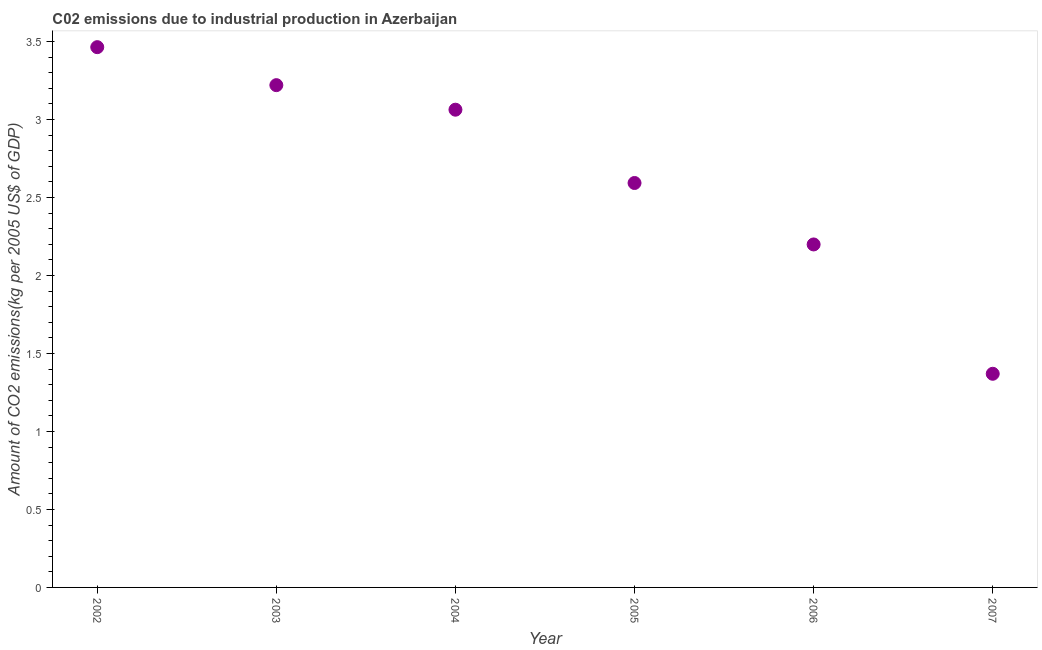What is the amount of co2 emissions in 2005?
Provide a short and direct response. 2.59. Across all years, what is the maximum amount of co2 emissions?
Your answer should be compact. 3.46. Across all years, what is the minimum amount of co2 emissions?
Your answer should be compact. 1.37. In which year was the amount of co2 emissions maximum?
Give a very brief answer. 2002. In which year was the amount of co2 emissions minimum?
Ensure brevity in your answer.  2007. What is the sum of the amount of co2 emissions?
Keep it short and to the point. 15.91. What is the difference between the amount of co2 emissions in 2005 and 2007?
Your response must be concise. 1.22. What is the average amount of co2 emissions per year?
Give a very brief answer. 2.65. What is the median amount of co2 emissions?
Your answer should be very brief. 2.83. In how many years, is the amount of co2 emissions greater than 0.4 kg per 2005 US$ of GDP?
Keep it short and to the point. 6. Do a majority of the years between 2005 and 2004 (inclusive) have amount of co2 emissions greater than 3.3 kg per 2005 US$ of GDP?
Offer a very short reply. No. What is the ratio of the amount of co2 emissions in 2003 to that in 2007?
Provide a succinct answer. 2.35. Is the amount of co2 emissions in 2003 less than that in 2005?
Offer a very short reply. No. What is the difference between the highest and the second highest amount of co2 emissions?
Provide a short and direct response. 0.24. What is the difference between the highest and the lowest amount of co2 emissions?
Offer a very short reply. 2.09. Does the amount of co2 emissions monotonically increase over the years?
Provide a succinct answer. No. What is the difference between two consecutive major ticks on the Y-axis?
Ensure brevity in your answer.  0.5. What is the title of the graph?
Make the answer very short. C02 emissions due to industrial production in Azerbaijan. What is the label or title of the X-axis?
Offer a very short reply. Year. What is the label or title of the Y-axis?
Provide a short and direct response. Amount of CO2 emissions(kg per 2005 US$ of GDP). What is the Amount of CO2 emissions(kg per 2005 US$ of GDP) in 2002?
Your response must be concise. 3.46. What is the Amount of CO2 emissions(kg per 2005 US$ of GDP) in 2003?
Give a very brief answer. 3.22. What is the Amount of CO2 emissions(kg per 2005 US$ of GDP) in 2004?
Keep it short and to the point. 3.06. What is the Amount of CO2 emissions(kg per 2005 US$ of GDP) in 2005?
Your answer should be very brief. 2.59. What is the Amount of CO2 emissions(kg per 2005 US$ of GDP) in 2006?
Your answer should be compact. 2.2. What is the Amount of CO2 emissions(kg per 2005 US$ of GDP) in 2007?
Your answer should be compact. 1.37. What is the difference between the Amount of CO2 emissions(kg per 2005 US$ of GDP) in 2002 and 2003?
Your answer should be very brief. 0.24. What is the difference between the Amount of CO2 emissions(kg per 2005 US$ of GDP) in 2002 and 2004?
Your answer should be compact. 0.4. What is the difference between the Amount of CO2 emissions(kg per 2005 US$ of GDP) in 2002 and 2005?
Keep it short and to the point. 0.87. What is the difference between the Amount of CO2 emissions(kg per 2005 US$ of GDP) in 2002 and 2006?
Your answer should be compact. 1.26. What is the difference between the Amount of CO2 emissions(kg per 2005 US$ of GDP) in 2002 and 2007?
Ensure brevity in your answer.  2.09. What is the difference between the Amount of CO2 emissions(kg per 2005 US$ of GDP) in 2003 and 2004?
Provide a succinct answer. 0.16. What is the difference between the Amount of CO2 emissions(kg per 2005 US$ of GDP) in 2003 and 2005?
Provide a short and direct response. 0.63. What is the difference between the Amount of CO2 emissions(kg per 2005 US$ of GDP) in 2003 and 2006?
Give a very brief answer. 1.02. What is the difference between the Amount of CO2 emissions(kg per 2005 US$ of GDP) in 2003 and 2007?
Ensure brevity in your answer.  1.85. What is the difference between the Amount of CO2 emissions(kg per 2005 US$ of GDP) in 2004 and 2005?
Provide a short and direct response. 0.47. What is the difference between the Amount of CO2 emissions(kg per 2005 US$ of GDP) in 2004 and 2006?
Offer a very short reply. 0.86. What is the difference between the Amount of CO2 emissions(kg per 2005 US$ of GDP) in 2004 and 2007?
Your response must be concise. 1.69. What is the difference between the Amount of CO2 emissions(kg per 2005 US$ of GDP) in 2005 and 2006?
Offer a terse response. 0.39. What is the difference between the Amount of CO2 emissions(kg per 2005 US$ of GDP) in 2005 and 2007?
Provide a short and direct response. 1.22. What is the difference between the Amount of CO2 emissions(kg per 2005 US$ of GDP) in 2006 and 2007?
Keep it short and to the point. 0.83. What is the ratio of the Amount of CO2 emissions(kg per 2005 US$ of GDP) in 2002 to that in 2003?
Your answer should be compact. 1.08. What is the ratio of the Amount of CO2 emissions(kg per 2005 US$ of GDP) in 2002 to that in 2004?
Give a very brief answer. 1.13. What is the ratio of the Amount of CO2 emissions(kg per 2005 US$ of GDP) in 2002 to that in 2005?
Ensure brevity in your answer.  1.34. What is the ratio of the Amount of CO2 emissions(kg per 2005 US$ of GDP) in 2002 to that in 2006?
Provide a short and direct response. 1.57. What is the ratio of the Amount of CO2 emissions(kg per 2005 US$ of GDP) in 2002 to that in 2007?
Offer a terse response. 2.53. What is the ratio of the Amount of CO2 emissions(kg per 2005 US$ of GDP) in 2003 to that in 2004?
Ensure brevity in your answer.  1.05. What is the ratio of the Amount of CO2 emissions(kg per 2005 US$ of GDP) in 2003 to that in 2005?
Keep it short and to the point. 1.24. What is the ratio of the Amount of CO2 emissions(kg per 2005 US$ of GDP) in 2003 to that in 2006?
Keep it short and to the point. 1.46. What is the ratio of the Amount of CO2 emissions(kg per 2005 US$ of GDP) in 2003 to that in 2007?
Offer a terse response. 2.35. What is the ratio of the Amount of CO2 emissions(kg per 2005 US$ of GDP) in 2004 to that in 2005?
Ensure brevity in your answer.  1.18. What is the ratio of the Amount of CO2 emissions(kg per 2005 US$ of GDP) in 2004 to that in 2006?
Ensure brevity in your answer.  1.39. What is the ratio of the Amount of CO2 emissions(kg per 2005 US$ of GDP) in 2004 to that in 2007?
Provide a succinct answer. 2.24. What is the ratio of the Amount of CO2 emissions(kg per 2005 US$ of GDP) in 2005 to that in 2006?
Your answer should be very brief. 1.18. What is the ratio of the Amount of CO2 emissions(kg per 2005 US$ of GDP) in 2005 to that in 2007?
Provide a short and direct response. 1.89. What is the ratio of the Amount of CO2 emissions(kg per 2005 US$ of GDP) in 2006 to that in 2007?
Make the answer very short. 1.6. 